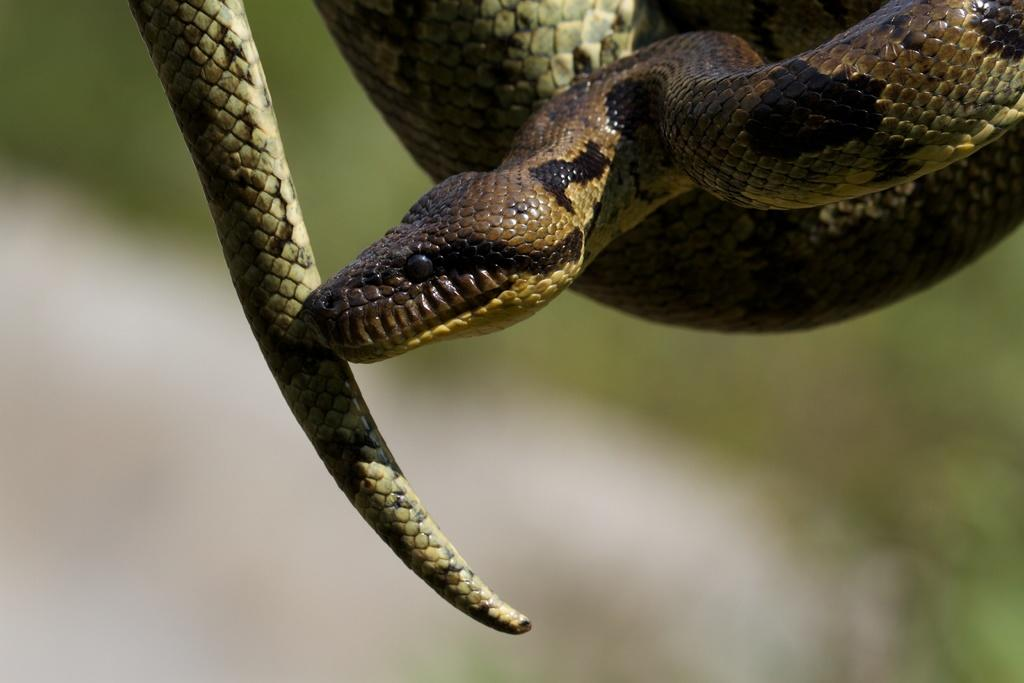What type of animal is in the image? There is a python in the image. What type of trick can be seen being performed by the python in the image? There is no trick being performed by the python in the image; it is simply a picture of a python. 